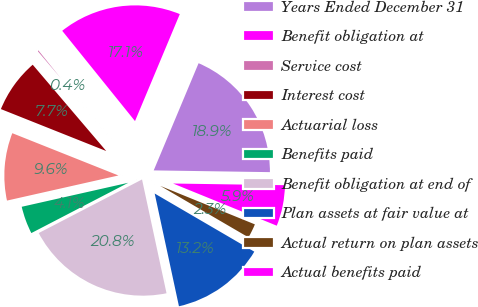Convert chart. <chart><loc_0><loc_0><loc_500><loc_500><pie_chart><fcel>Years Ended December 31<fcel>Benefit obligation at<fcel>Service cost<fcel>Interest cost<fcel>Actuarial loss<fcel>Benefits paid<fcel>Benefit obligation at end of<fcel>Plan assets at fair value at<fcel>Actual return on plan assets<fcel>Actual benefits paid<nl><fcel>18.93%<fcel>17.11%<fcel>0.43%<fcel>7.74%<fcel>9.56%<fcel>4.09%<fcel>20.76%<fcel>13.22%<fcel>2.26%<fcel>5.91%<nl></chart> 